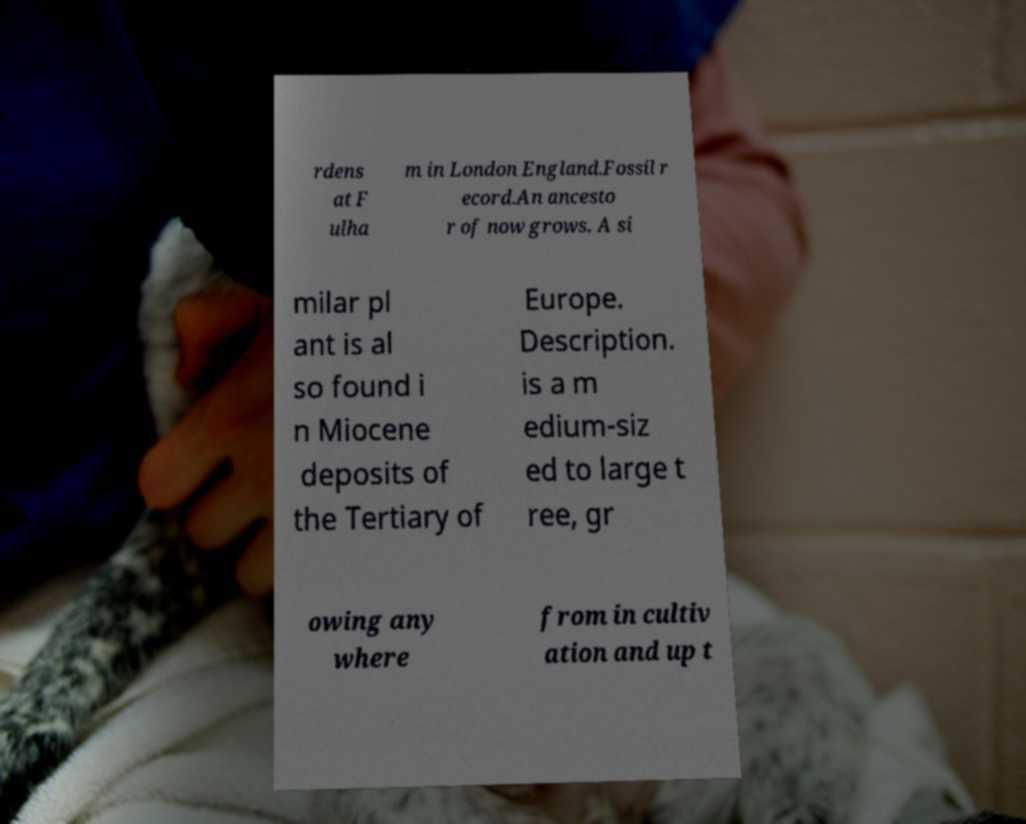There's text embedded in this image that I need extracted. Can you transcribe it verbatim? rdens at F ulha m in London England.Fossil r ecord.An ancesto r of now grows. A si milar pl ant is al so found i n Miocene deposits of the Tertiary of Europe. Description. is a m edium-siz ed to large t ree, gr owing any where from in cultiv ation and up t 